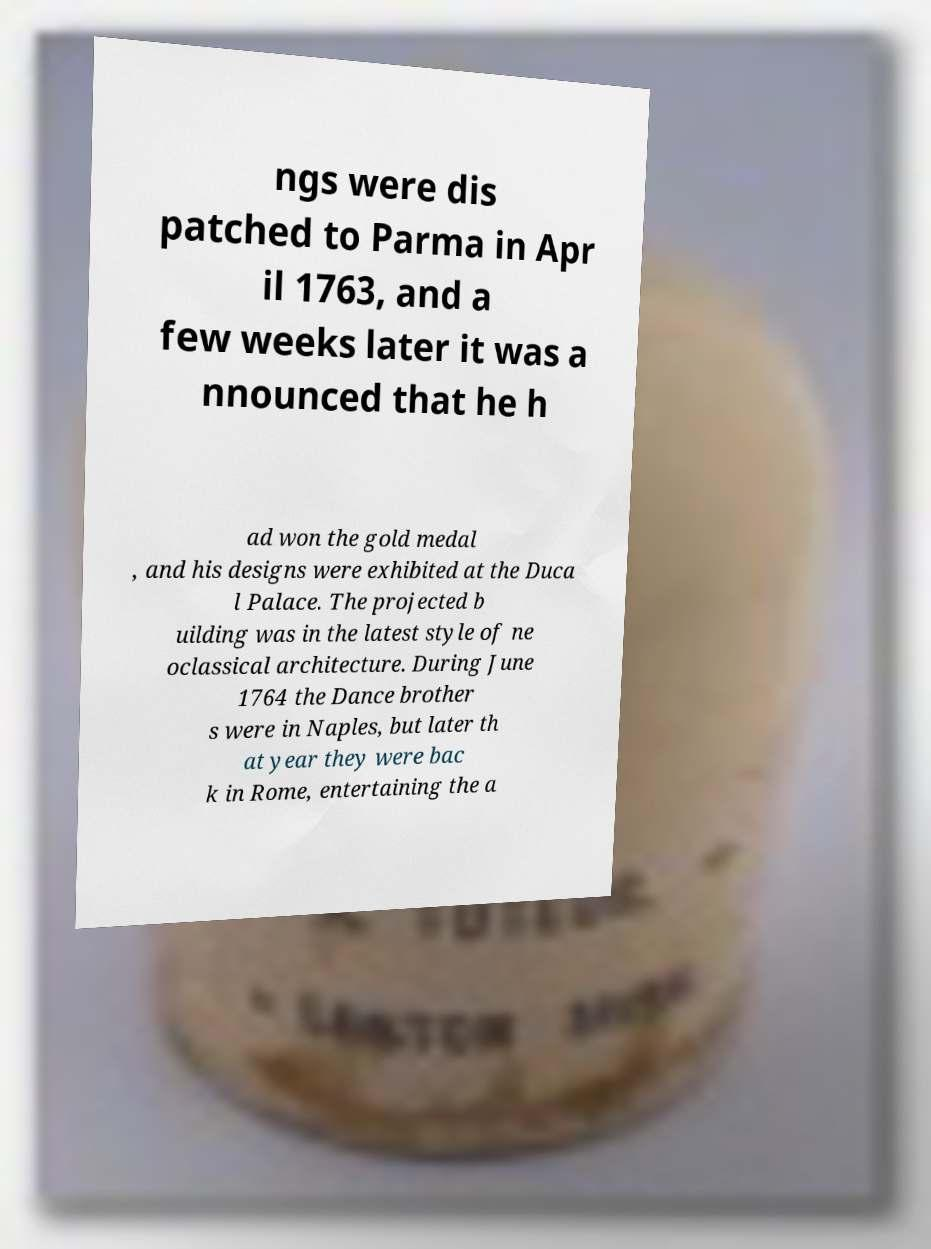Can you read and provide the text displayed in the image?This photo seems to have some interesting text. Can you extract and type it out for me? ngs were dis patched to Parma in Apr il 1763, and a few weeks later it was a nnounced that he h ad won the gold medal , and his designs were exhibited at the Duca l Palace. The projected b uilding was in the latest style of ne oclassical architecture. During June 1764 the Dance brother s were in Naples, but later th at year they were bac k in Rome, entertaining the a 